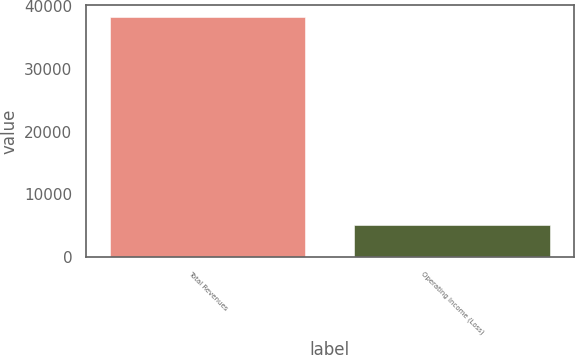<chart> <loc_0><loc_0><loc_500><loc_500><bar_chart><fcel>Total Revenues<fcel>Operating Income (Loss)<nl><fcel>38236<fcel>5069<nl></chart> 